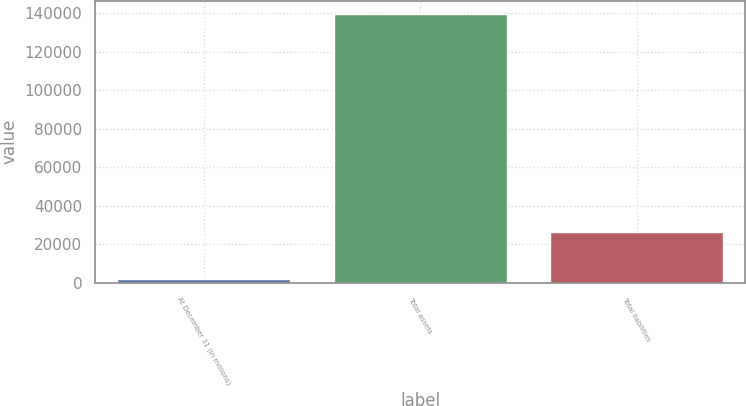Convert chart. <chart><loc_0><loc_0><loc_500><loc_500><bar_chart><fcel>At December 31 (in millions)<fcel>Total assets<fcel>Total liabilities<nl><fcel>2012<fcel>139681<fcel>26529<nl></chart> 